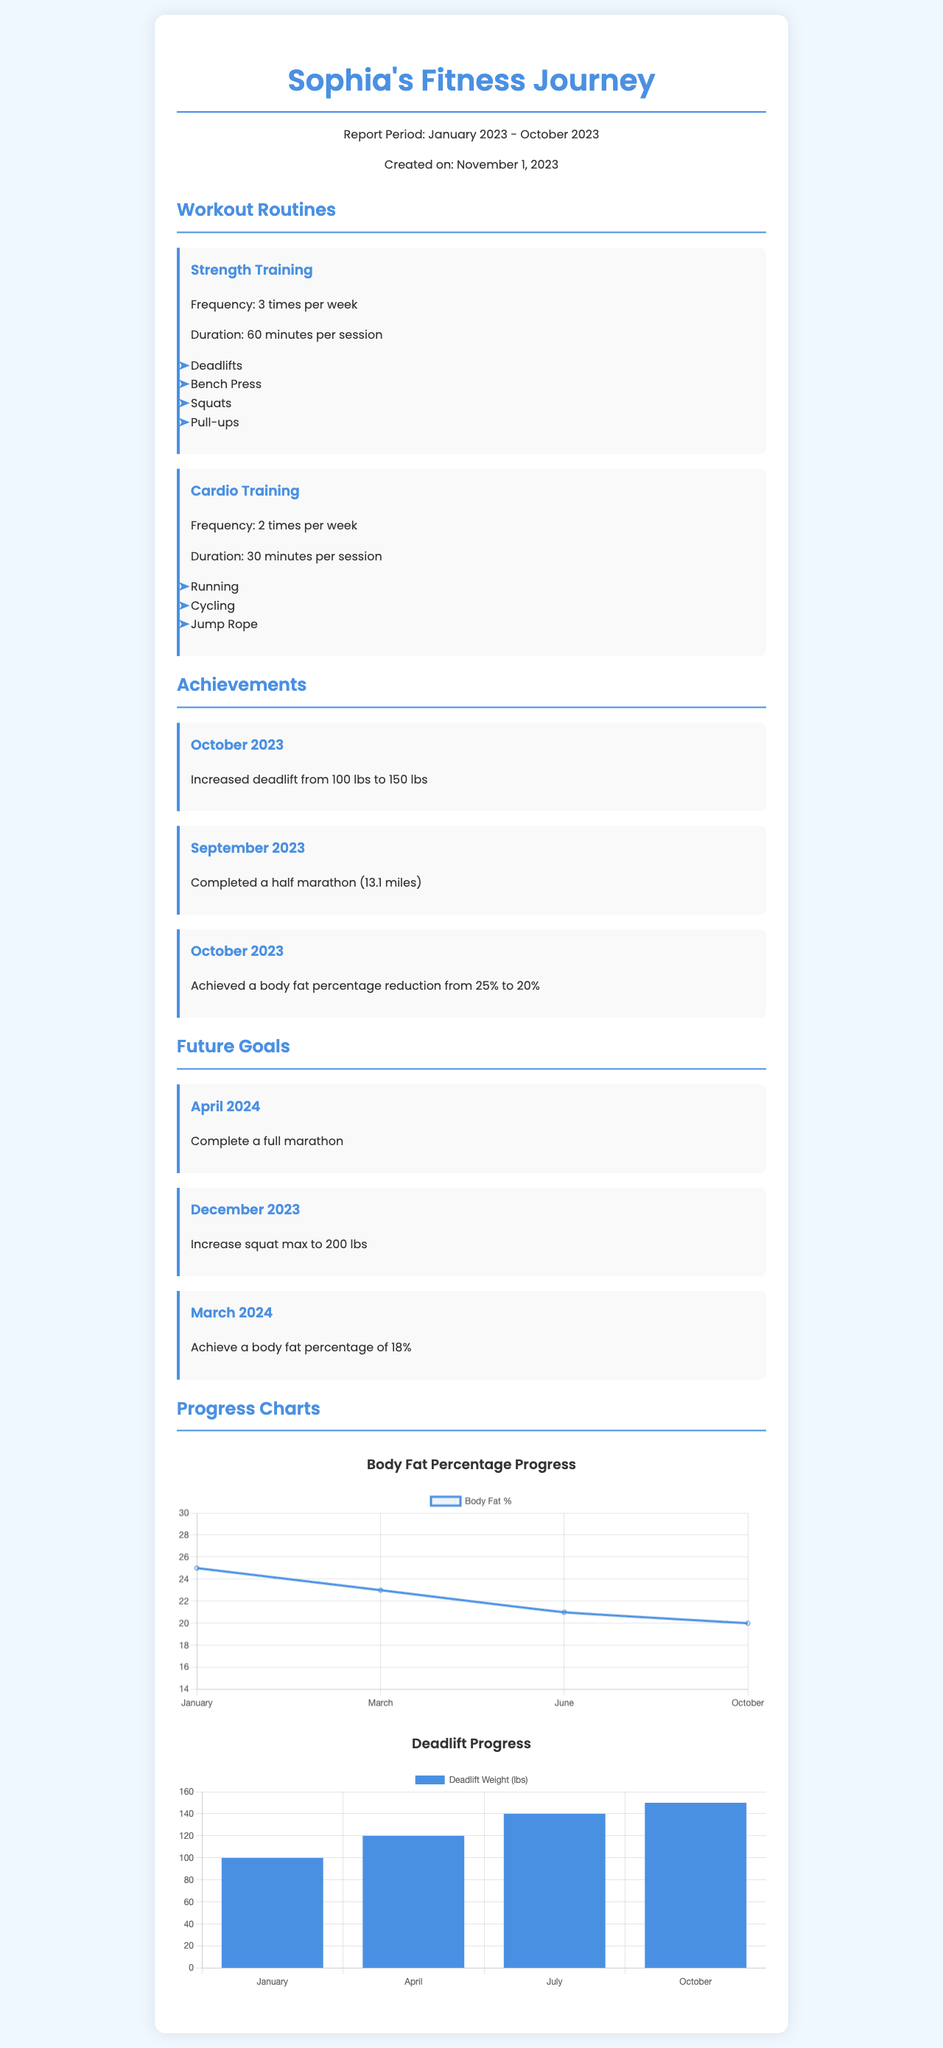What is the report period? The report period is specified at the top of the document and includes the months that the fitness journey covers.
Answer: January 2023 - October 2023 How many times per week does Sophia do strength training? The frequency of strength training is mentioned under the workout routines section.
Answer: 3 times per week What is Sophia's current body fat percentage? The current body fat percentage is listed in the achievements section and reflects the latest recorded value.
Answer: 20% What weight did Sophia increase her deadlift to? The specific achievement of increasing her deadlift weight is noted in the achievements section.
Answer: 150 lbs What is one of Sophia's future goals? Future goals are outlined at the end of the document, indicating specific targets she aims to reach.
Answer: Complete a full marathon How much did Sophia reduce her body fat percentage from the previous measurement? This requires comparing two values from the achievements section that detail her progress.
Answer: 5% What type of chart is shown for body fat percentage? The document specifies the type of chart used to represent progress in body fat percentage.
Answer: Line chart What exercise is listed under cardio training? A part of the routine section lists specific exercises for cardio training.
Answer: Running How many achievements are listed in October 2023? The number of achievements is noted by counting the separate entries made in that month within the achievements section.
Answer: 2 achievements 